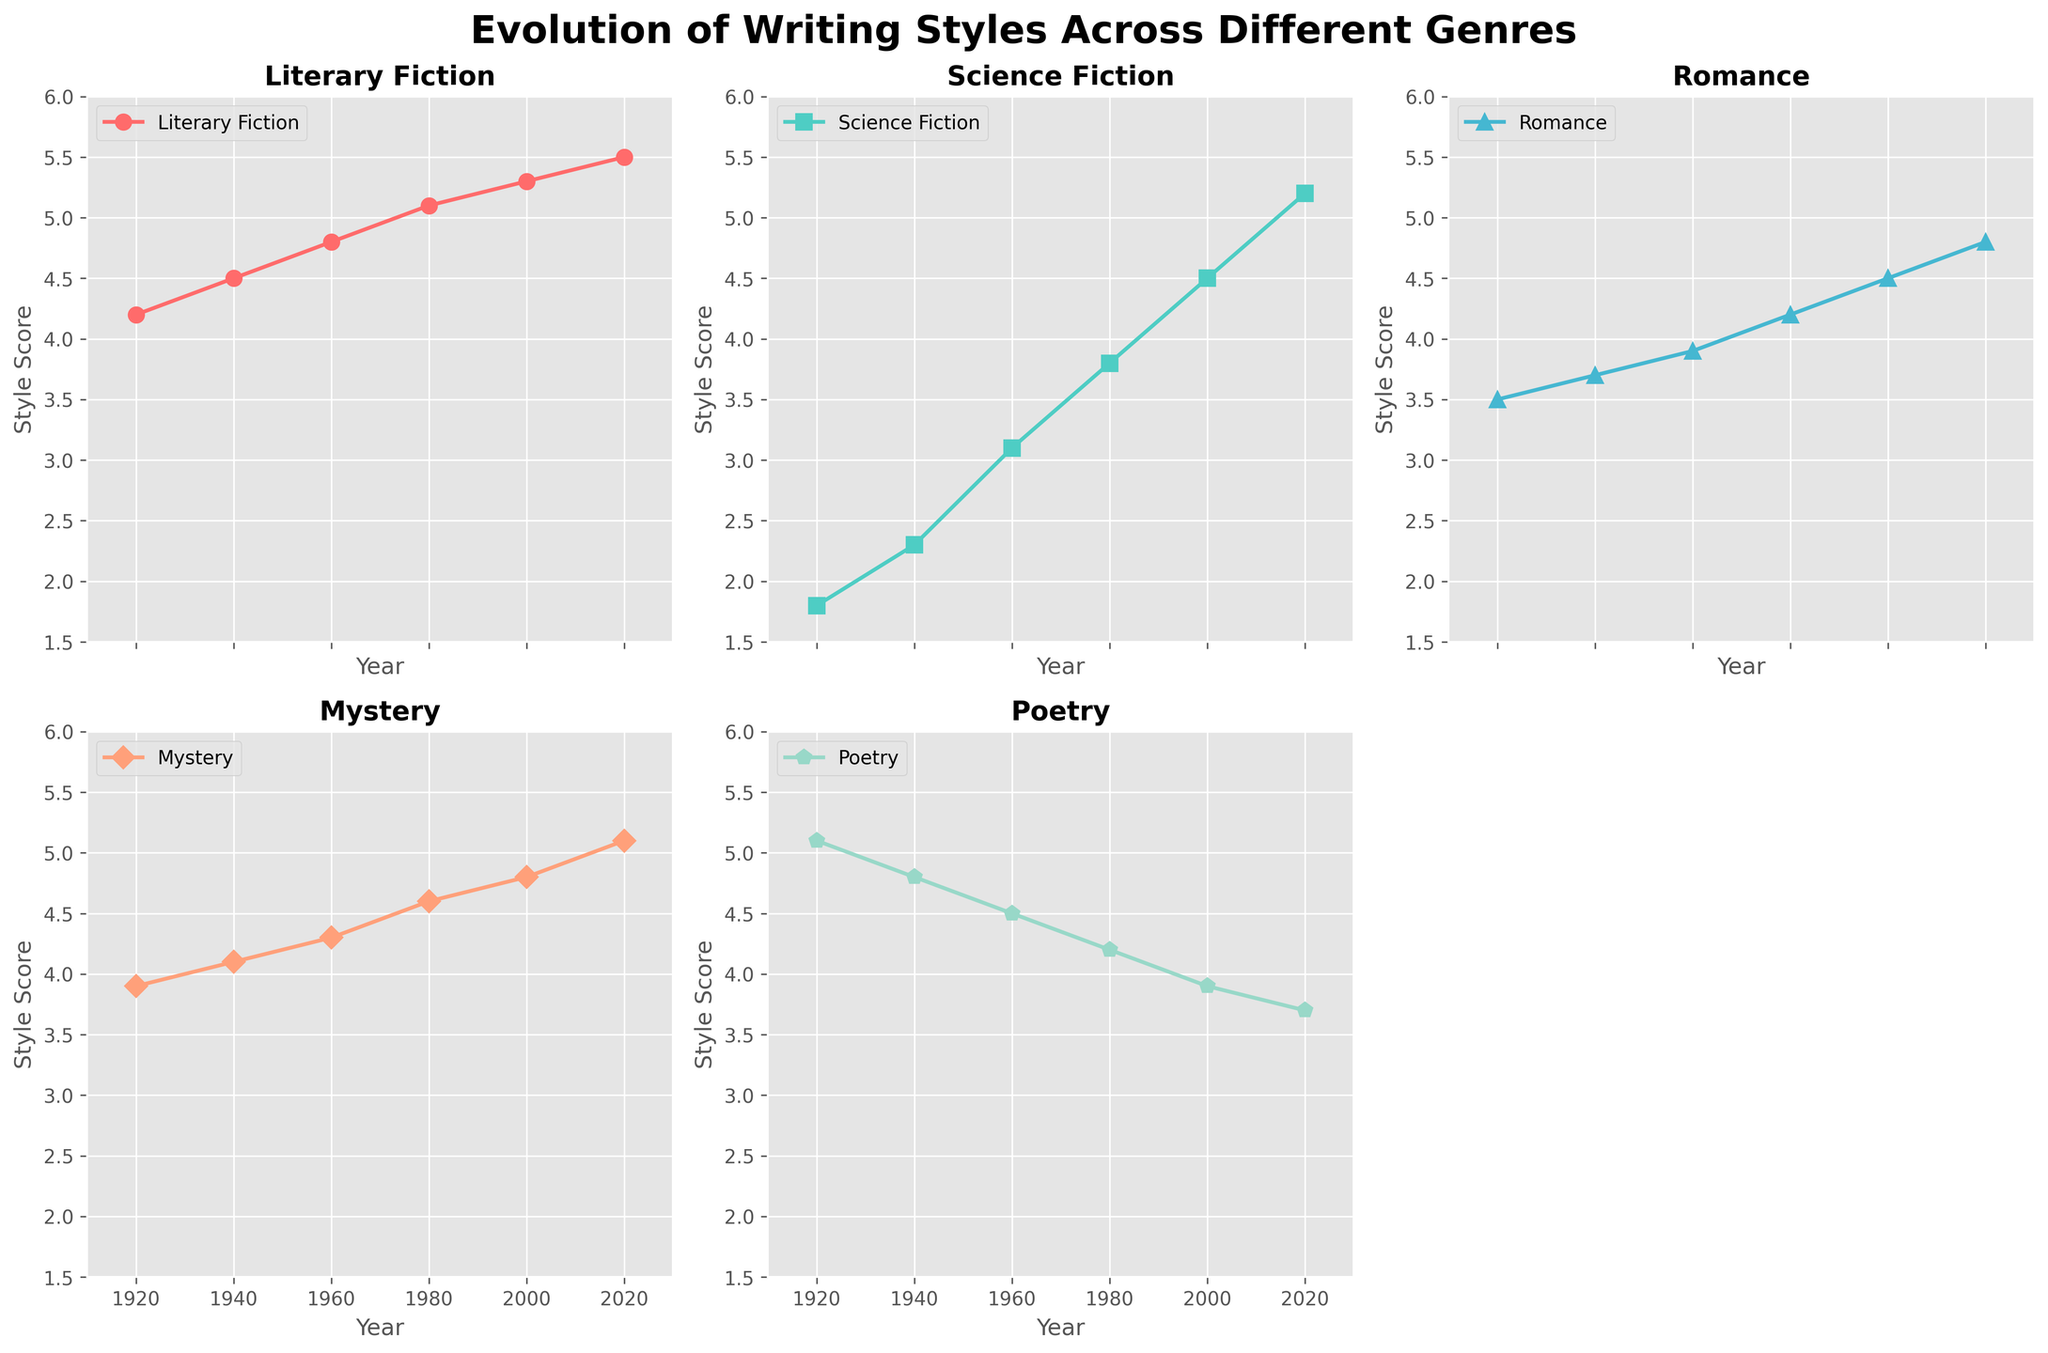what is the title of the figure? The title is displayed at the top of the figure, written in bold and large font. It gives an overview of what the figure is about: "Evolution of Writing Styles Across Different Genres".
Answer: Evolution of Writing Styles Across Different Genres what are the y-axis limits across all subplots? The y-axis limits are the same for all genres, spanning from 1.5 to 6. This can be observed by looking at the smallest and largest values marked on the y-axis.
Answer: 1.5 to 6 what genre had a consistent increase in style score over the years? By examining the line trends in each subplot, the genre that shows a steady rise in its style score from 1920 to 2020 is "Science Fiction". The line in its subplot moves upward without any decline.
Answer: Science Fiction in which year did "Poetry" have the highest style score? Looking at the "Poetry" subplot, the highest point on the line is at 1920, where it reaches a score of 5.1.
Answer: 1920 compare the style score of "Literary Fiction" and "Romance" in 2000. Which one is higher? In the subplots, the points for the year 2000 show that "Literary Fiction" has a score of 5.3 and "Romance" has a score of 4.5. More simply, comparing the two values, "Literary Fiction" has a higher score.
Answer: Literary Fiction which genre experienced a decline in style score between 1980 and 2020? Observing the trend lines, "Poetry" shows a decrease in its style score from 4.2 in 1980 to 3.7 in 2020. No other genre shows a consistent decline during this period.
Answer: Poetry what is the average style score for "Mystery" from 1920 to 2020? The scores for "Mystery" over the years 1920, 1940, 1960, 1980, 2000, and 2020 are 3.9, 4.1, 4.3, 4.6, 4.8, and 5.1 respectively. Sum them (3.9 + 4.1 + 4.3 + 4.6 + 4.8 + 5.1 = 26.8) and then divide by 6 to find the average. 26.8 / 6 = 4.47.
Answer: 4.47 how many subplots are present in the figure? There are five genres being plotted in individual subplots. However, the grid structure suggests there are six positions, with one left blank, so there are a total of 5 subplots visible.
Answer: 5 what is the color used for the "Romance" genre line? In the "Romance" subplot, the line is colored orange which stands out against the other colors used for different genres.
Answer: Orange which genre has the least style score in 1920? In 1920, the subplot for each genre shows that "Science Fiction" has the lowest style score, which is 1.8.
Answer: Science Fiction 